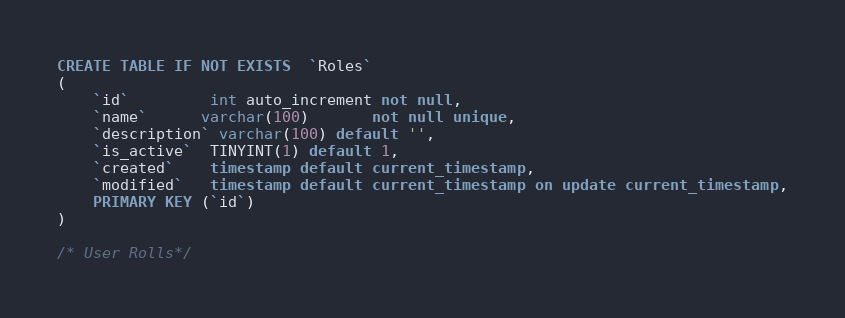<code> <loc_0><loc_0><loc_500><loc_500><_SQL_>CREATE TABLE IF NOT EXISTS  `Roles`
(
    `id`         int auto_increment not null,
    `name`      varchar(100)       not null unique,
    `description` varchar(100) default '',
    `is_active`  TINYINT(1) default 1,
    `created`    timestamp default current_timestamp,
    `modified`   timestamp default current_timestamp on update current_timestamp,
    PRIMARY KEY (`id`)
)

/* User Rolls*/
</code> 